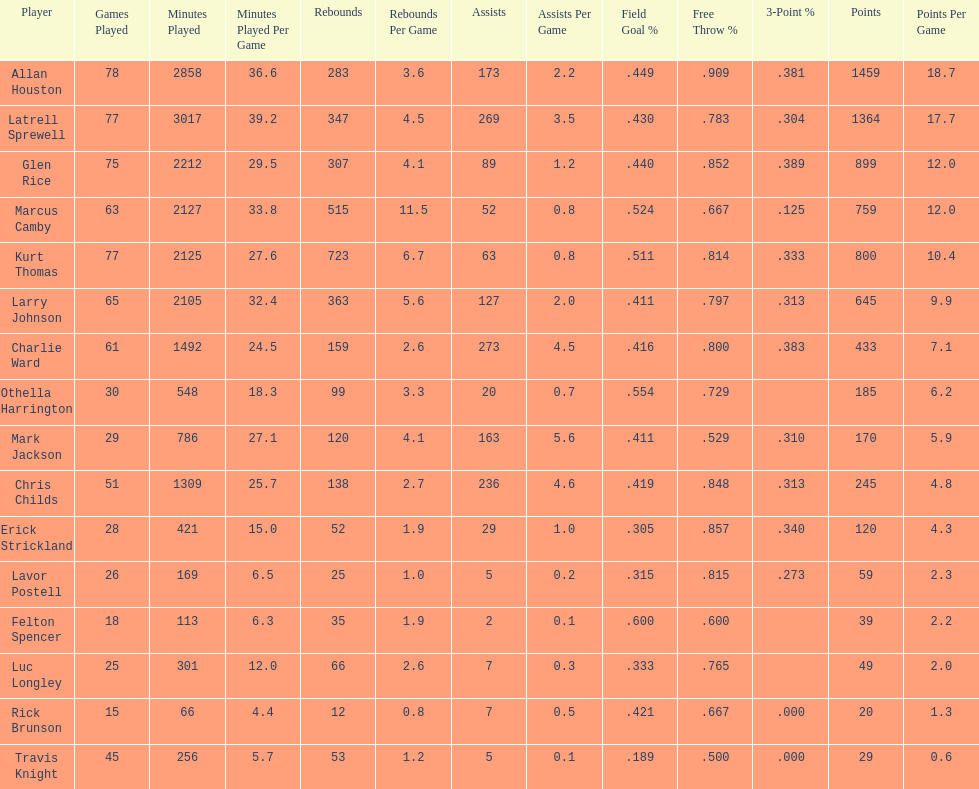How many players had a field goal percentage higher than .500? 4. I'm looking to parse the entire table for insights. Could you assist me with that? {'header': ['Player', 'Games Played', 'Minutes Played', 'Minutes Played Per Game', 'Rebounds', 'Rebounds Per Game', 'Assists', 'Assists Per Game', 'Field Goal\xa0%', 'Free Throw\xa0%', '3-Point\xa0%', 'Points', 'Points Per Game'], 'rows': [['Allan Houston', '78', '2858', '36.6', '283', '3.6', '173', '2.2', '.449', '.909', '.381', '1459', '18.7'], ['Latrell Sprewell', '77', '3017', '39.2', '347', '4.5', '269', '3.5', '.430', '.783', '.304', '1364', '17.7'], ['Glen Rice', '75', '2212', '29.5', '307', '4.1', '89', '1.2', '.440', '.852', '.389', '899', '12.0'], ['Marcus Camby', '63', '2127', '33.8', '515', '11.5', '52', '0.8', '.524', '.667', '.125', '759', '12.0'], ['Kurt Thomas', '77', '2125', '27.6', '723', '6.7', '63', '0.8', '.511', '.814', '.333', '800', '10.4'], ['Larry Johnson', '65', '2105', '32.4', '363', '5.6', '127', '2.0', '.411', '.797', '.313', '645', '9.9'], ['Charlie Ward', '61', '1492', '24.5', '159', '2.6', '273', '4.5', '.416', '.800', '.383', '433', '7.1'], ['Othella Harrington', '30', '548', '18.3', '99', '3.3', '20', '0.7', '.554', '.729', '', '185', '6.2'], ['Mark Jackson', '29', '786', '27.1', '120', '4.1', '163', '5.6', '.411', '.529', '.310', '170', '5.9'], ['Chris Childs', '51', '1309', '25.7', '138', '2.7', '236', '4.6', '.419', '.848', '.313', '245', '4.8'], ['Erick Strickland', '28', '421', '15.0', '52', '1.9', '29', '1.0', '.305', '.857', '.340', '120', '4.3'], ['Lavor Postell', '26', '169', '6.5', '25', '1.0', '5', '0.2', '.315', '.815', '.273', '59', '2.3'], ['Felton Spencer', '18', '113', '6.3', '35', '1.9', '2', '0.1', '.600', '.600', '', '39', '2.2'], ['Luc Longley', '25', '301', '12.0', '66', '2.6', '7', '0.3', '.333', '.765', '', '49', '2.0'], ['Rick Brunson', '15', '66', '4.4', '12', '0.8', '7', '0.5', '.421', '.667', '.000', '20', '1.3'], ['Travis Knight', '45', '256', '5.7', '53', '1.2', '5', '0.1', '.189', '.500', '.000', '29', '0.6']]} 